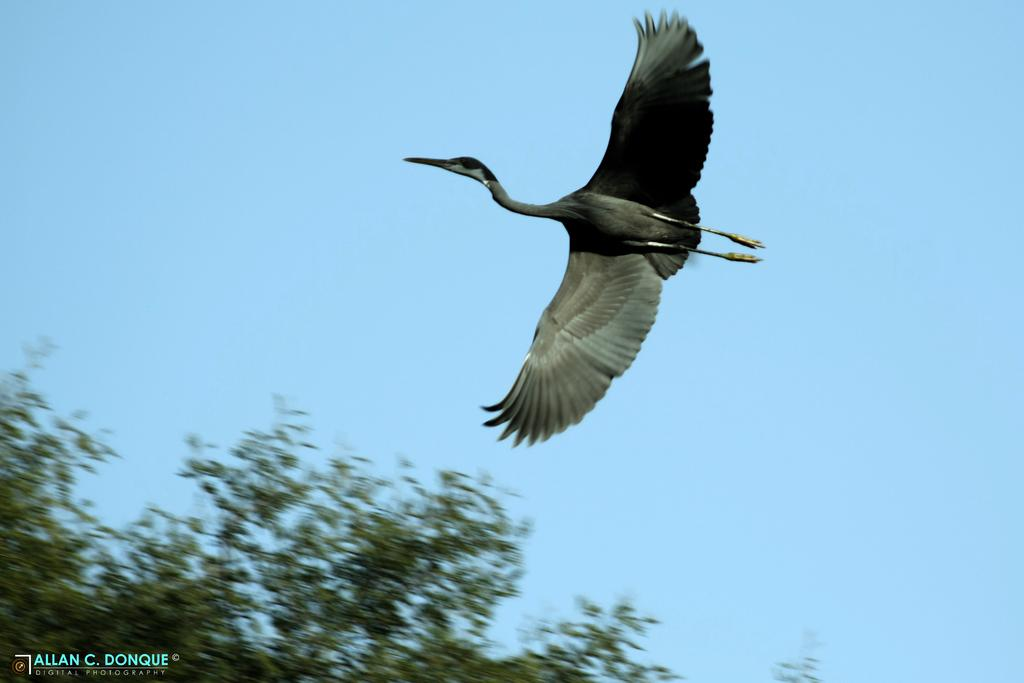What is located in the left bottom of the image? There are trees in the left bottom of the image. What can be seen in the middle of the image? There is a bird in the middle of the image. What colors are present on the bird? The bird is in black and grey color. What is the bird doing in the image? The bird is flying in the sky. What is visible in the background of the image? The sky is visible in the background of the image. What is the color of the sky in the image? The sky is blue in color. What type of pipe is the bird using to fly in the image? There is no pipe present in the image; the bird is flying using its wings. What caption is written on the bird in the image? There is no caption present on the bird in the image; it is a photograph or illustration without text. 